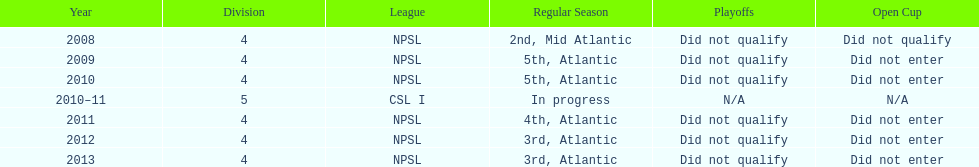In which most recent year did they rank 5th? 2010. 